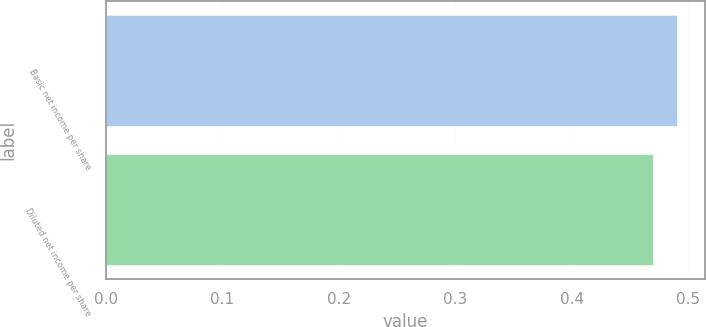Convert chart to OTSL. <chart><loc_0><loc_0><loc_500><loc_500><bar_chart><fcel>Basic net income per share<fcel>Diluted net income per share<nl><fcel>0.49<fcel>0.47<nl></chart> 